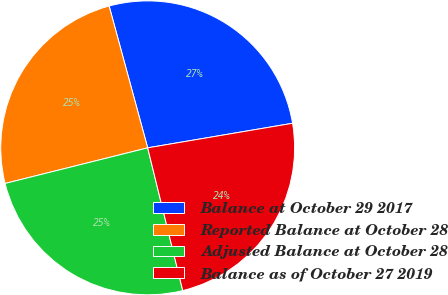Convert chart to OTSL. <chart><loc_0><loc_0><loc_500><loc_500><pie_chart><fcel>Balance at October 29 2017<fcel>Reported Balance at October 28<fcel>Adjusted Balance at October 28<fcel>Balance as of October 27 2019<nl><fcel>26.55%<fcel>24.67%<fcel>24.94%<fcel>23.84%<nl></chart> 